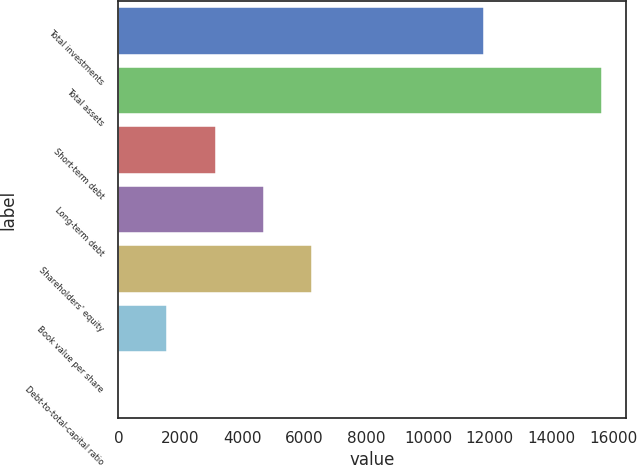Convert chart to OTSL. <chart><loc_0><loc_0><loc_500><loc_500><bar_chart><fcel>Total investments<fcel>Total assets<fcel>Short-term debt<fcel>Long-term debt<fcel>Shareholders' equity<fcel>Book value per share<fcel>Debt-to-total-capital ratio<nl><fcel>11801<fcel>15635<fcel>3139.08<fcel>4701.07<fcel>6263.06<fcel>1577.09<fcel>15.1<nl></chart> 